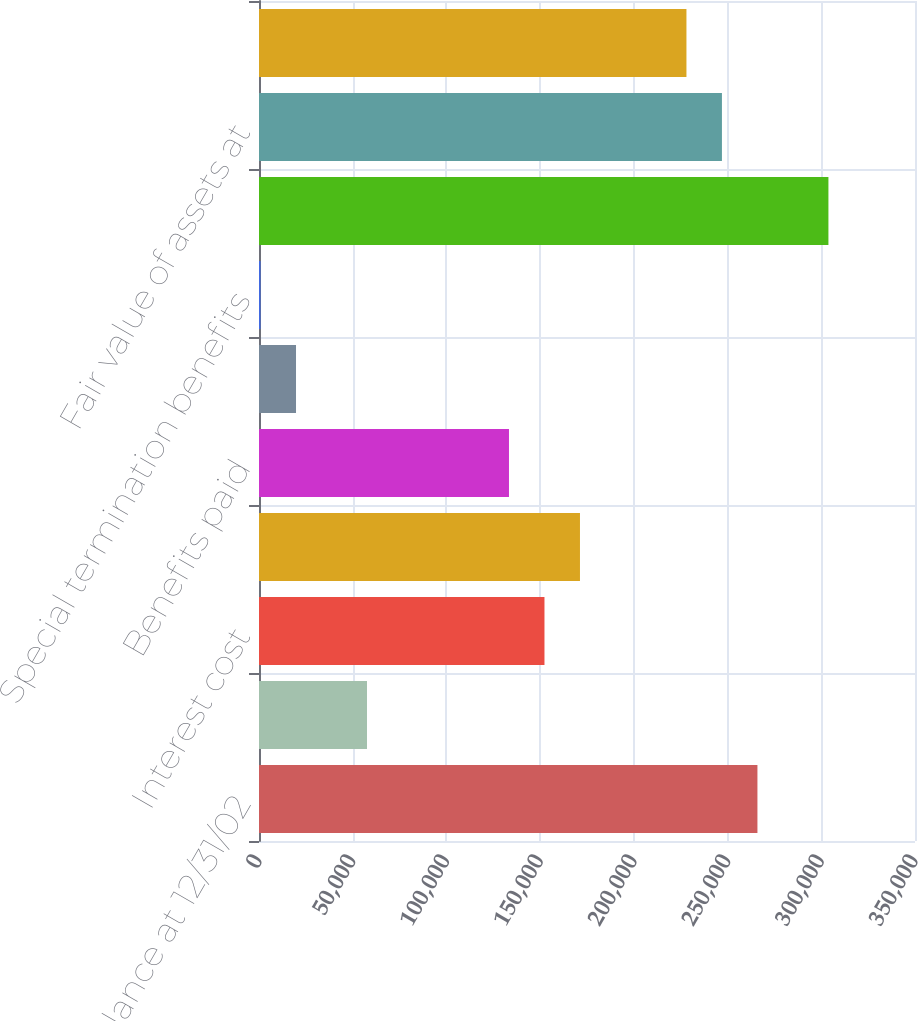Convert chart. <chart><loc_0><loc_0><loc_500><loc_500><bar_chart><fcel>Balance at 12/31/02<fcel>Service cost<fcel>Interest cost<fcel>Actuarial loss<fcel>Benefits paid<fcel>Curtailment loss<fcel>Special termination benefits<fcel>Balance at 12/31/03<fcel>Fair value of assets at<fcel>Actual return on plan assets<nl><fcel>265933<fcel>57622.9<fcel>152309<fcel>171247<fcel>133372<fcel>19748.3<fcel>811<fcel>303808<fcel>246996<fcel>228059<nl></chart> 